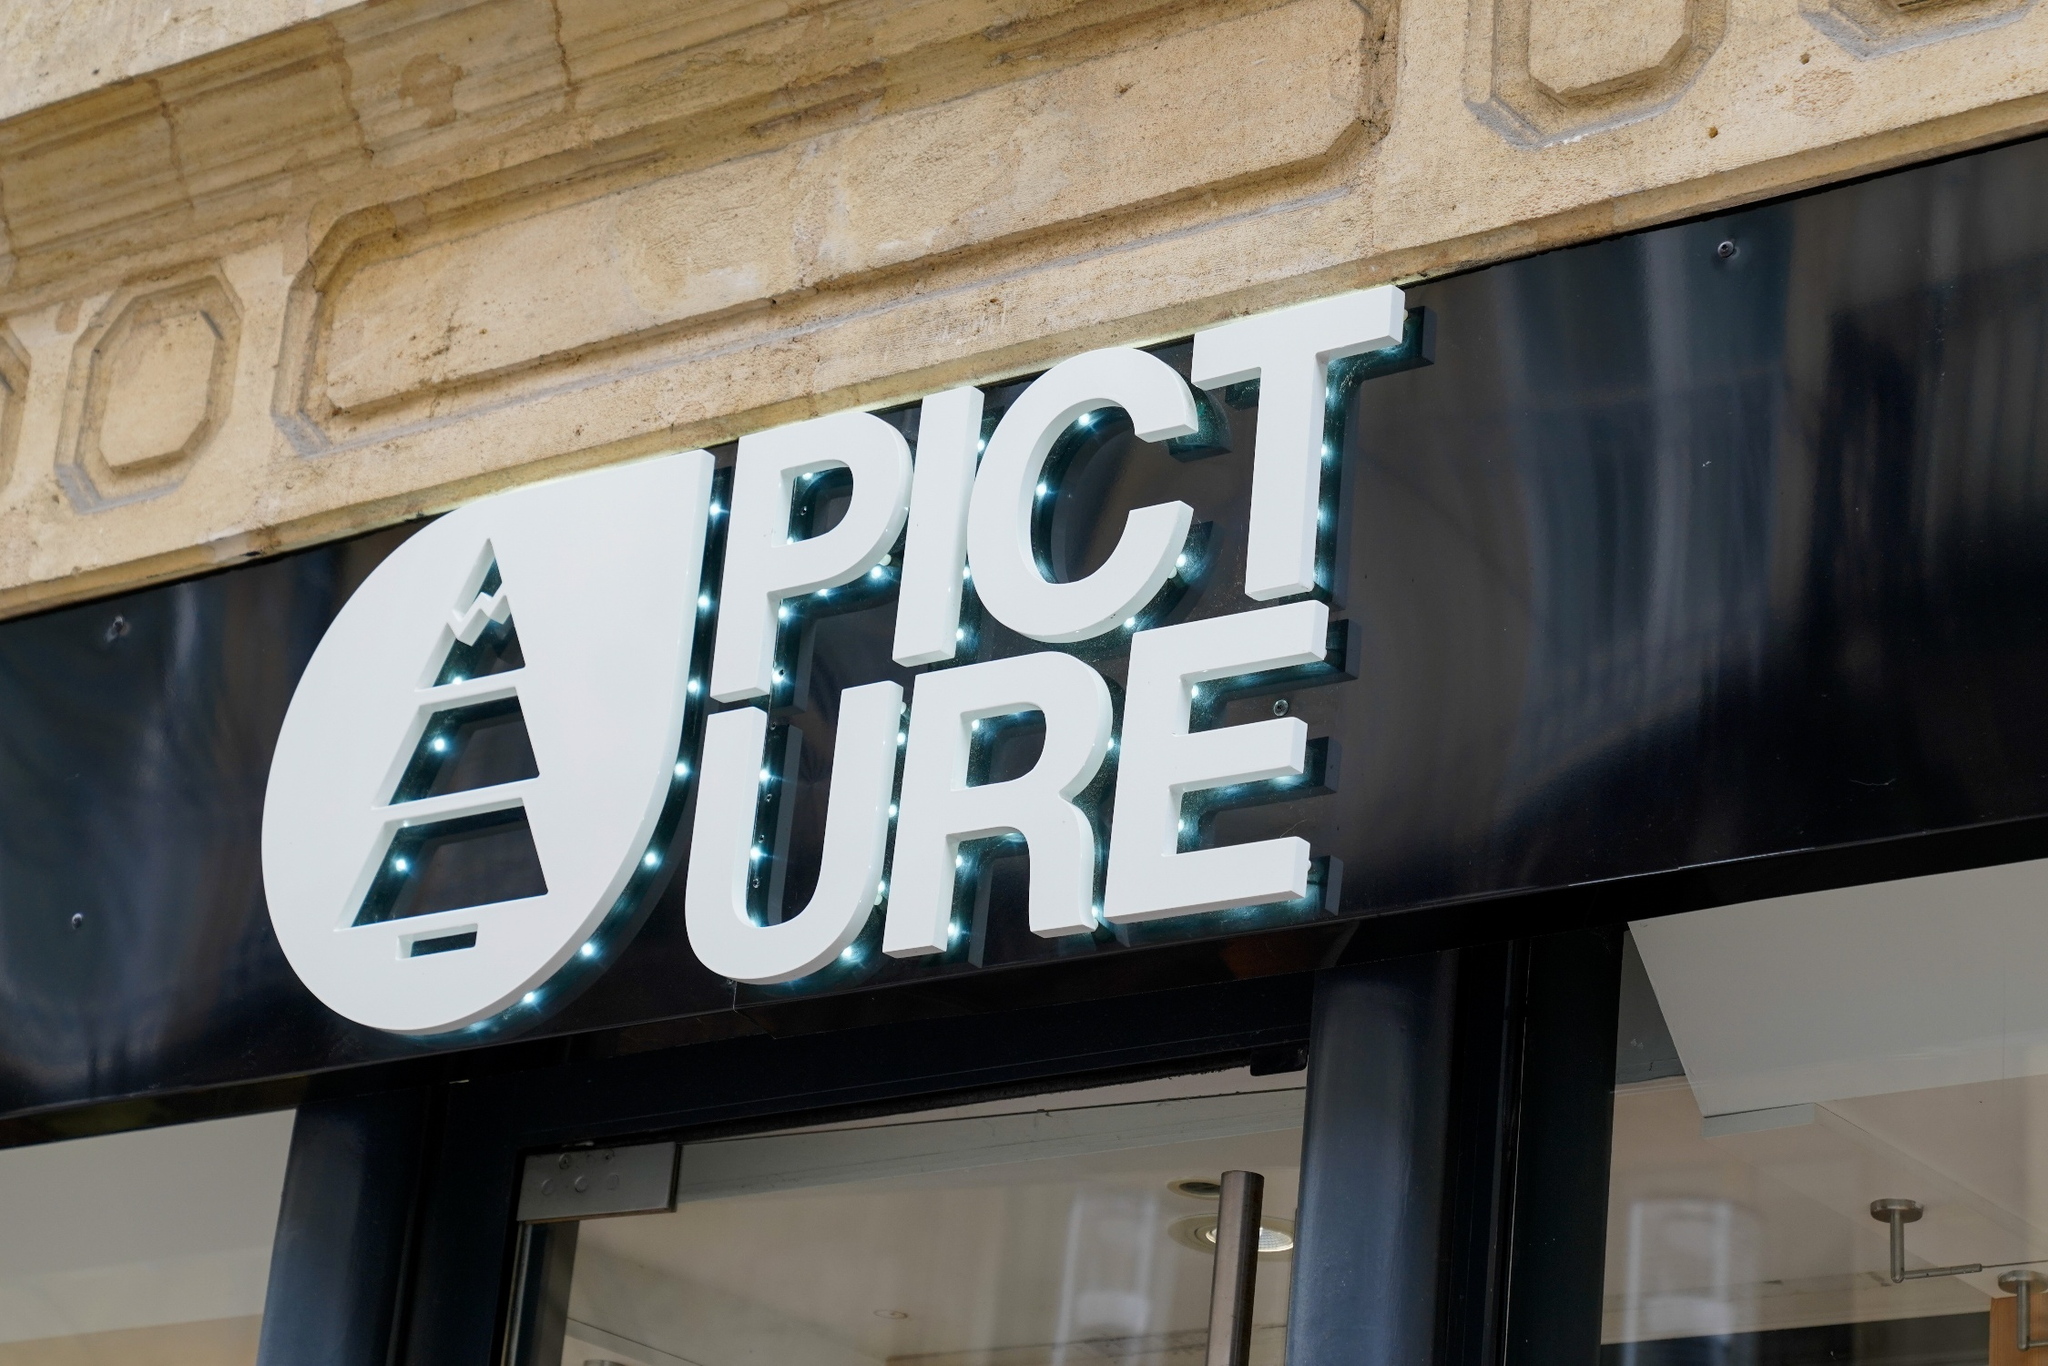Can you describe the ambiance and potential style of the store based on its exterior? Based on the exterior, the store exudes a chic and contemporary ambiance. The stone facade and modern aesthetics suggest a business that values both functionality and style. The crisp white letters on the sign, with their clean and modern font, along with the innovative triangle symbol, indicate a brand that is youthful yet sophisticated. The glass doors hint at an open and welcoming interior, possibly with minimalist design showcasing curated high-quality products. 